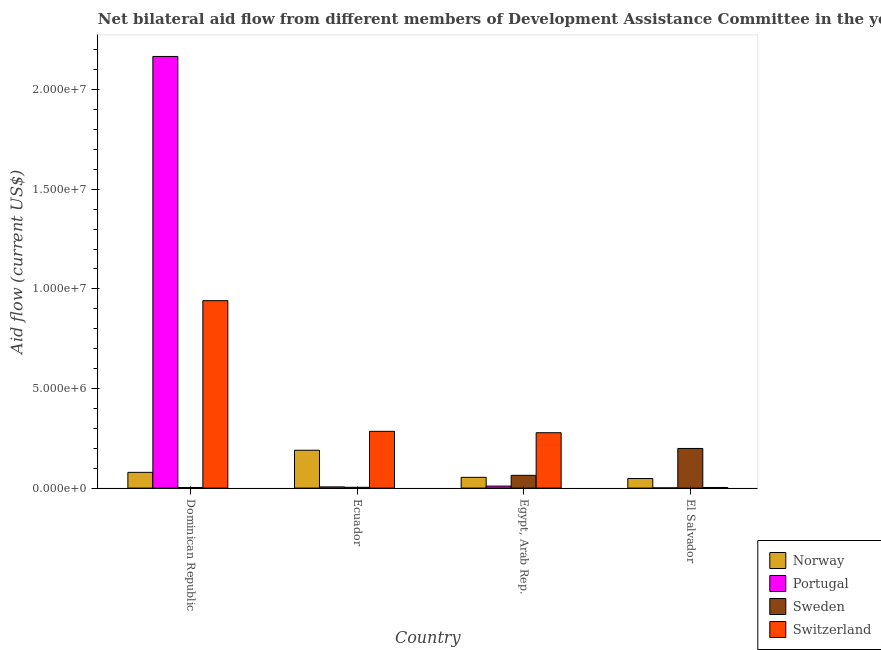How many groups of bars are there?
Your response must be concise. 4. Are the number of bars on each tick of the X-axis equal?
Offer a very short reply. Yes. How many bars are there on the 3rd tick from the left?
Make the answer very short. 4. How many bars are there on the 2nd tick from the right?
Offer a very short reply. 4. What is the label of the 4th group of bars from the left?
Your answer should be very brief. El Salvador. In how many cases, is the number of bars for a given country not equal to the number of legend labels?
Offer a very short reply. 0. What is the amount of aid given by switzerland in El Salvador?
Your response must be concise. 3.00e+04. Across all countries, what is the maximum amount of aid given by sweden?
Your answer should be very brief. 1.99e+06. Across all countries, what is the minimum amount of aid given by switzerland?
Your answer should be very brief. 3.00e+04. In which country was the amount of aid given by sweden maximum?
Make the answer very short. El Salvador. In which country was the amount of aid given by switzerland minimum?
Your answer should be very brief. El Salvador. What is the total amount of aid given by sweden in the graph?
Your response must be concise. 2.70e+06. What is the difference between the amount of aid given by switzerland in Dominican Republic and that in Ecuador?
Provide a succinct answer. 6.56e+06. What is the difference between the amount of aid given by switzerland in Ecuador and the amount of aid given by portugal in Egypt, Arab Rep.?
Offer a terse response. 2.75e+06. What is the average amount of aid given by sweden per country?
Provide a succinct answer. 6.75e+05. What is the difference between the amount of aid given by norway and amount of aid given by portugal in Dominican Republic?
Your answer should be very brief. -2.09e+07. What is the ratio of the amount of aid given by norway in Egypt, Arab Rep. to that in El Salvador?
Your answer should be compact. 1.12. Is the amount of aid given by portugal in Dominican Republic less than that in El Salvador?
Offer a very short reply. No. Is the difference between the amount of aid given by switzerland in Dominican Republic and Ecuador greater than the difference between the amount of aid given by sweden in Dominican Republic and Ecuador?
Offer a terse response. Yes. What is the difference between the highest and the second highest amount of aid given by sweden?
Ensure brevity in your answer.  1.35e+06. What is the difference between the highest and the lowest amount of aid given by switzerland?
Your answer should be compact. 9.38e+06. Is it the case that in every country, the sum of the amount of aid given by norway and amount of aid given by switzerland is greater than the sum of amount of aid given by portugal and amount of aid given by sweden?
Your answer should be compact. Yes. What does the 2nd bar from the left in Dominican Republic represents?
Offer a very short reply. Portugal. What does the 1st bar from the right in Dominican Republic represents?
Provide a succinct answer. Switzerland. Are the values on the major ticks of Y-axis written in scientific E-notation?
Give a very brief answer. Yes. Does the graph contain any zero values?
Offer a very short reply. No. Does the graph contain grids?
Provide a short and direct response. No. Where does the legend appear in the graph?
Keep it short and to the point. Bottom right. How many legend labels are there?
Your response must be concise. 4. How are the legend labels stacked?
Provide a short and direct response. Vertical. What is the title of the graph?
Your answer should be very brief. Net bilateral aid flow from different members of Development Assistance Committee in the year 2006. What is the Aid flow (current US$) in Norway in Dominican Republic?
Keep it short and to the point. 7.90e+05. What is the Aid flow (current US$) of Portugal in Dominican Republic?
Provide a succinct answer. 2.17e+07. What is the Aid flow (current US$) of Switzerland in Dominican Republic?
Give a very brief answer. 9.41e+06. What is the Aid flow (current US$) in Norway in Ecuador?
Provide a succinct answer. 1.90e+06. What is the Aid flow (current US$) in Portugal in Ecuador?
Give a very brief answer. 6.00e+04. What is the Aid flow (current US$) of Sweden in Ecuador?
Offer a very short reply. 4.00e+04. What is the Aid flow (current US$) in Switzerland in Ecuador?
Give a very brief answer. 2.85e+06. What is the Aid flow (current US$) in Norway in Egypt, Arab Rep.?
Offer a very short reply. 5.40e+05. What is the Aid flow (current US$) in Sweden in Egypt, Arab Rep.?
Provide a short and direct response. 6.40e+05. What is the Aid flow (current US$) of Switzerland in Egypt, Arab Rep.?
Make the answer very short. 2.78e+06. What is the Aid flow (current US$) of Portugal in El Salvador?
Give a very brief answer. 10000. What is the Aid flow (current US$) of Sweden in El Salvador?
Offer a very short reply. 1.99e+06. What is the Aid flow (current US$) of Switzerland in El Salvador?
Make the answer very short. 3.00e+04. Across all countries, what is the maximum Aid flow (current US$) in Norway?
Ensure brevity in your answer.  1.90e+06. Across all countries, what is the maximum Aid flow (current US$) of Portugal?
Your answer should be compact. 2.17e+07. Across all countries, what is the maximum Aid flow (current US$) of Sweden?
Ensure brevity in your answer.  1.99e+06. Across all countries, what is the maximum Aid flow (current US$) in Switzerland?
Ensure brevity in your answer.  9.41e+06. Across all countries, what is the minimum Aid flow (current US$) in Portugal?
Offer a very short reply. 10000. What is the total Aid flow (current US$) in Norway in the graph?
Provide a short and direct response. 3.71e+06. What is the total Aid flow (current US$) in Portugal in the graph?
Provide a short and direct response. 2.18e+07. What is the total Aid flow (current US$) in Sweden in the graph?
Provide a succinct answer. 2.70e+06. What is the total Aid flow (current US$) of Switzerland in the graph?
Offer a very short reply. 1.51e+07. What is the difference between the Aid flow (current US$) in Norway in Dominican Republic and that in Ecuador?
Provide a succinct answer. -1.11e+06. What is the difference between the Aid flow (current US$) of Portugal in Dominican Republic and that in Ecuador?
Offer a terse response. 2.16e+07. What is the difference between the Aid flow (current US$) in Switzerland in Dominican Republic and that in Ecuador?
Make the answer very short. 6.56e+06. What is the difference between the Aid flow (current US$) of Portugal in Dominican Republic and that in Egypt, Arab Rep.?
Offer a terse response. 2.16e+07. What is the difference between the Aid flow (current US$) in Sweden in Dominican Republic and that in Egypt, Arab Rep.?
Your answer should be very brief. -6.10e+05. What is the difference between the Aid flow (current US$) of Switzerland in Dominican Republic and that in Egypt, Arab Rep.?
Your answer should be very brief. 6.63e+06. What is the difference between the Aid flow (current US$) in Portugal in Dominican Republic and that in El Salvador?
Provide a succinct answer. 2.17e+07. What is the difference between the Aid flow (current US$) of Sweden in Dominican Republic and that in El Salvador?
Offer a terse response. -1.96e+06. What is the difference between the Aid flow (current US$) in Switzerland in Dominican Republic and that in El Salvador?
Your answer should be very brief. 9.38e+06. What is the difference between the Aid flow (current US$) of Norway in Ecuador and that in Egypt, Arab Rep.?
Your answer should be very brief. 1.36e+06. What is the difference between the Aid flow (current US$) of Portugal in Ecuador and that in Egypt, Arab Rep.?
Make the answer very short. -4.00e+04. What is the difference between the Aid flow (current US$) of Sweden in Ecuador and that in Egypt, Arab Rep.?
Provide a short and direct response. -6.00e+05. What is the difference between the Aid flow (current US$) of Norway in Ecuador and that in El Salvador?
Ensure brevity in your answer.  1.42e+06. What is the difference between the Aid flow (current US$) in Portugal in Ecuador and that in El Salvador?
Provide a succinct answer. 5.00e+04. What is the difference between the Aid flow (current US$) of Sweden in Ecuador and that in El Salvador?
Keep it short and to the point. -1.95e+06. What is the difference between the Aid flow (current US$) of Switzerland in Ecuador and that in El Salvador?
Your answer should be very brief. 2.82e+06. What is the difference between the Aid flow (current US$) of Portugal in Egypt, Arab Rep. and that in El Salvador?
Provide a short and direct response. 9.00e+04. What is the difference between the Aid flow (current US$) in Sweden in Egypt, Arab Rep. and that in El Salvador?
Your answer should be very brief. -1.35e+06. What is the difference between the Aid flow (current US$) of Switzerland in Egypt, Arab Rep. and that in El Salvador?
Offer a very short reply. 2.75e+06. What is the difference between the Aid flow (current US$) of Norway in Dominican Republic and the Aid flow (current US$) of Portugal in Ecuador?
Ensure brevity in your answer.  7.30e+05. What is the difference between the Aid flow (current US$) of Norway in Dominican Republic and the Aid flow (current US$) of Sweden in Ecuador?
Make the answer very short. 7.50e+05. What is the difference between the Aid flow (current US$) of Norway in Dominican Republic and the Aid flow (current US$) of Switzerland in Ecuador?
Ensure brevity in your answer.  -2.06e+06. What is the difference between the Aid flow (current US$) of Portugal in Dominican Republic and the Aid flow (current US$) of Sweden in Ecuador?
Give a very brief answer. 2.16e+07. What is the difference between the Aid flow (current US$) of Portugal in Dominican Republic and the Aid flow (current US$) of Switzerland in Ecuador?
Make the answer very short. 1.88e+07. What is the difference between the Aid flow (current US$) of Sweden in Dominican Republic and the Aid flow (current US$) of Switzerland in Ecuador?
Provide a short and direct response. -2.82e+06. What is the difference between the Aid flow (current US$) in Norway in Dominican Republic and the Aid flow (current US$) in Portugal in Egypt, Arab Rep.?
Offer a very short reply. 6.90e+05. What is the difference between the Aid flow (current US$) in Norway in Dominican Republic and the Aid flow (current US$) in Sweden in Egypt, Arab Rep.?
Give a very brief answer. 1.50e+05. What is the difference between the Aid flow (current US$) in Norway in Dominican Republic and the Aid flow (current US$) in Switzerland in Egypt, Arab Rep.?
Give a very brief answer. -1.99e+06. What is the difference between the Aid flow (current US$) of Portugal in Dominican Republic and the Aid flow (current US$) of Sweden in Egypt, Arab Rep.?
Provide a short and direct response. 2.10e+07. What is the difference between the Aid flow (current US$) in Portugal in Dominican Republic and the Aid flow (current US$) in Switzerland in Egypt, Arab Rep.?
Make the answer very short. 1.89e+07. What is the difference between the Aid flow (current US$) of Sweden in Dominican Republic and the Aid flow (current US$) of Switzerland in Egypt, Arab Rep.?
Your answer should be compact. -2.75e+06. What is the difference between the Aid flow (current US$) in Norway in Dominican Republic and the Aid flow (current US$) in Portugal in El Salvador?
Offer a very short reply. 7.80e+05. What is the difference between the Aid flow (current US$) in Norway in Dominican Republic and the Aid flow (current US$) in Sweden in El Salvador?
Provide a succinct answer. -1.20e+06. What is the difference between the Aid flow (current US$) in Norway in Dominican Republic and the Aid flow (current US$) in Switzerland in El Salvador?
Your answer should be very brief. 7.60e+05. What is the difference between the Aid flow (current US$) in Portugal in Dominican Republic and the Aid flow (current US$) in Sweden in El Salvador?
Offer a terse response. 1.97e+07. What is the difference between the Aid flow (current US$) of Portugal in Dominican Republic and the Aid flow (current US$) of Switzerland in El Salvador?
Offer a terse response. 2.16e+07. What is the difference between the Aid flow (current US$) in Sweden in Dominican Republic and the Aid flow (current US$) in Switzerland in El Salvador?
Make the answer very short. 0. What is the difference between the Aid flow (current US$) of Norway in Ecuador and the Aid flow (current US$) of Portugal in Egypt, Arab Rep.?
Provide a short and direct response. 1.80e+06. What is the difference between the Aid flow (current US$) of Norway in Ecuador and the Aid flow (current US$) of Sweden in Egypt, Arab Rep.?
Ensure brevity in your answer.  1.26e+06. What is the difference between the Aid flow (current US$) in Norway in Ecuador and the Aid flow (current US$) in Switzerland in Egypt, Arab Rep.?
Your answer should be compact. -8.80e+05. What is the difference between the Aid flow (current US$) of Portugal in Ecuador and the Aid flow (current US$) of Sweden in Egypt, Arab Rep.?
Keep it short and to the point. -5.80e+05. What is the difference between the Aid flow (current US$) of Portugal in Ecuador and the Aid flow (current US$) of Switzerland in Egypt, Arab Rep.?
Provide a succinct answer. -2.72e+06. What is the difference between the Aid flow (current US$) of Sweden in Ecuador and the Aid flow (current US$) of Switzerland in Egypt, Arab Rep.?
Offer a terse response. -2.74e+06. What is the difference between the Aid flow (current US$) in Norway in Ecuador and the Aid flow (current US$) in Portugal in El Salvador?
Make the answer very short. 1.89e+06. What is the difference between the Aid flow (current US$) in Norway in Ecuador and the Aid flow (current US$) in Sweden in El Salvador?
Offer a very short reply. -9.00e+04. What is the difference between the Aid flow (current US$) in Norway in Ecuador and the Aid flow (current US$) in Switzerland in El Salvador?
Ensure brevity in your answer.  1.87e+06. What is the difference between the Aid flow (current US$) of Portugal in Ecuador and the Aid flow (current US$) of Sweden in El Salvador?
Ensure brevity in your answer.  -1.93e+06. What is the difference between the Aid flow (current US$) in Portugal in Ecuador and the Aid flow (current US$) in Switzerland in El Salvador?
Make the answer very short. 3.00e+04. What is the difference between the Aid flow (current US$) of Norway in Egypt, Arab Rep. and the Aid flow (current US$) of Portugal in El Salvador?
Keep it short and to the point. 5.30e+05. What is the difference between the Aid flow (current US$) of Norway in Egypt, Arab Rep. and the Aid flow (current US$) of Sweden in El Salvador?
Keep it short and to the point. -1.45e+06. What is the difference between the Aid flow (current US$) of Norway in Egypt, Arab Rep. and the Aid flow (current US$) of Switzerland in El Salvador?
Your answer should be compact. 5.10e+05. What is the difference between the Aid flow (current US$) in Portugal in Egypt, Arab Rep. and the Aid flow (current US$) in Sweden in El Salvador?
Ensure brevity in your answer.  -1.89e+06. What is the difference between the Aid flow (current US$) of Portugal in Egypt, Arab Rep. and the Aid flow (current US$) of Switzerland in El Salvador?
Keep it short and to the point. 7.00e+04. What is the average Aid flow (current US$) in Norway per country?
Ensure brevity in your answer.  9.28e+05. What is the average Aid flow (current US$) in Portugal per country?
Your response must be concise. 5.46e+06. What is the average Aid flow (current US$) of Sweden per country?
Offer a very short reply. 6.75e+05. What is the average Aid flow (current US$) of Switzerland per country?
Ensure brevity in your answer.  3.77e+06. What is the difference between the Aid flow (current US$) of Norway and Aid flow (current US$) of Portugal in Dominican Republic?
Ensure brevity in your answer.  -2.09e+07. What is the difference between the Aid flow (current US$) of Norway and Aid flow (current US$) of Sweden in Dominican Republic?
Your answer should be very brief. 7.60e+05. What is the difference between the Aid flow (current US$) of Norway and Aid flow (current US$) of Switzerland in Dominican Republic?
Your answer should be very brief. -8.62e+06. What is the difference between the Aid flow (current US$) in Portugal and Aid flow (current US$) in Sweden in Dominican Republic?
Provide a short and direct response. 2.16e+07. What is the difference between the Aid flow (current US$) in Portugal and Aid flow (current US$) in Switzerland in Dominican Republic?
Make the answer very short. 1.23e+07. What is the difference between the Aid flow (current US$) in Sweden and Aid flow (current US$) in Switzerland in Dominican Republic?
Make the answer very short. -9.38e+06. What is the difference between the Aid flow (current US$) of Norway and Aid flow (current US$) of Portugal in Ecuador?
Your answer should be compact. 1.84e+06. What is the difference between the Aid flow (current US$) in Norway and Aid flow (current US$) in Sweden in Ecuador?
Make the answer very short. 1.86e+06. What is the difference between the Aid flow (current US$) in Norway and Aid flow (current US$) in Switzerland in Ecuador?
Provide a short and direct response. -9.50e+05. What is the difference between the Aid flow (current US$) of Portugal and Aid flow (current US$) of Switzerland in Ecuador?
Your answer should be compact. -2.79e+06. What is the difference between the Aid flow (current US$) of Sweden and Aid flow (current US$) of Switzerland in Ecuador?
Your answer should be compact. -2.81e+06. What is the difference between the Aid flow (current US$) of Norway and Aid flow (current US$) of Portugal in Egypt, Arab Rep.?
Provide a succinct answer. 4.40e+05. What is the difference between the Aid flow (current US$) of Norway and Aid flow (current US$) of Switzerland in Egypt, Arab Rep.?
Offer a very short reply. -2.24e+06. What is the difference between the Aid flow (current US$) of Portugal and Aid flow (current US$) of Sweden in Egypt, Arab Rep.?
Keep it short and to the point. -5.40e+05. What is the difference between the Aid flow (current US$) of Portugal and Aid flow (current US$) of Switzerland in Egypt, Arab Rep.?
Give a very brief answer. -2.68e+06. What is the difference between the Aid flow (current US$) of Sweden and Aid flow (current US$) of Switzerland in Egypt, Arab Rep.?
Your response must be concise. -2.14e+06. What is the difference between the Aid flow (current US$) in Norway and Aid flow (current US$) in Sweden in El Salvador?
Your answer should be very brief. -1.51e+06. What is the difference between the Aid flow (current US$) in Norway and Aid flow (current US$) in Switzerland in El Salvador?
Offer a very short reply. 4.50e+05. What is the difference between the Aid flow (current US$) in Portugal and Aid flow (current US$) in Sweden in El Salvador?
Provide a short and direct response. -1.98e+06. What is the difference between the Aid flow (current US$) of Portugal and Aid flow (current US$) of Switzerland in El Salvador?
Ensure brevity in your answer.  -2.00e+04. What is the difference between the Aid flow (current US$) of Sweden and Aid flow (current US$) of Switzerland in El Salvador?
Offer a terse response. 1.96e+06. What is the ratio of the Aid flow (current US$) in Norway in Dominican Republic to that in Ecuador?
Provide a succinct answer. 0.42. What is the ratio of the Aid flow (current US$) in Portugal in Dominican Republic to that in Ecuador?
Ensure brevity in your answer.  361.17. What is the ratio of the Aid flow (current US$) of Switzerland in Dominican Republic to that in Ecuador?
Make the answer very short. 3.3. What is the ratio of the Aid flow (current US$) in Norway in Dominican Republic to that in Egypt, Arab Rep.?
Your answer should be very brief. 1.46. What is the ratio of the Aid flow (current US$) of Portugal in Dominican Republic to that in Egypt, Arab Rep.?
Give a very brief answer. 216.7. What is the ratio of the Aid flow (current US$) in Sweden in Dominican Republic to that in Egypt, Arab Rep.?
Your answer should be very brief. 0.05. What is the ratio of the Aid flow (current US$) in Switzerland in Dominican Republic to that in Egypt, Arab Rep.?
Provide a succinct answer. 3.38. What is the ratio of the Aid flow (current US$) of Norway in Dominican Republic to that in El Salvador?
Ensure brevity in your answer.  1.65. What is the ratio of the Aid flow (current US$) of Portugal in Dominican Republic to that in El Salvador?
Keep it short and to the point. 2167. What is the ratio of the Aid flow (current US$) of Sweden in Dominican Republic to that in El Salvador?
Keep it short and to the point. 0.02. What is the ratio of the Aid flow (current US$) in Switzerland in Dominican Republic to that in El Salvador?
Keep it short and to the point. 313.67. What is the ratio of the Aid flow (current US$) of Norway in Ecuador to that in Egypt, Arab Rep.?
Give a very brief answer. 3.52. What is the ratio of the Aid flow (current US$) in Sweden in Ecuador to that in Egypt, Arab Rep.?
Your response must be concise. 0.06. What is the ratio of the Aid flow (current US$) in Switzerland in Ecuador to that in Egypt, Arab Rep.?
Offer a very short reply. 1.03. What is the ratio of the Aid flow (current US$) of Norway in Ecuador to that in El Salvador?
Provide a succinct answer. 3.96. What is the ratio of the Aid flow (current US$) of Sweden in Ecuador to that in El Salvador?
Ensure brevity in your answer.  0.02. What is the ratio of the Aid flow (current US$) of Norway in Egypt, Arab Rep. to that in El Salvador?
Your answer should be compact. 1.12. What is the ratio of the Aid flow (current US$) in Sweden in Egypt, Arab Rep. to that in El Salvador?
Your answer should be very brief. 0.32. What is the ratio of the Aid flow (current US$) of Switzerland in Egypt, Arab Rep. to that in El Salvador?
Your response must be concise. 92.67. What is the difference between the highest and the second highest Aid flow (current US$) in Norway?
Your answer should be compact. 1.11e+06. What is the difference between the highest and the second highest Aid flow (current US$) in Portugal?
Offer a very short reply. 2.16e+07. What is the difference between the highest and the second highest Aid flow (current US$) in Sweden?
Offer a terse response. 1.35e+06. What is the difference between the highest and the second highest Aid flow (current US$) of Switzerland?
Keep it short and to the point. 6.56e+06. What is the difference between the highest and the lowest Aid flow (current US$) of Norway?
Your answer should be very brief. 1.42e+06. What is the difference between the highest and the lowest Aid flow (current US$) in Portugal?
Keep it short and to the point. 2.17e+07. What is the difference between the highest and the lowest Aid flow (current US$) of Sweden?
Keep it short and to the point. 1.96e+06. What is the difference between the highest and the lowest Aid flow (current US$) of Switzerland?
Provide a succinct answer. 9.38e+06. 